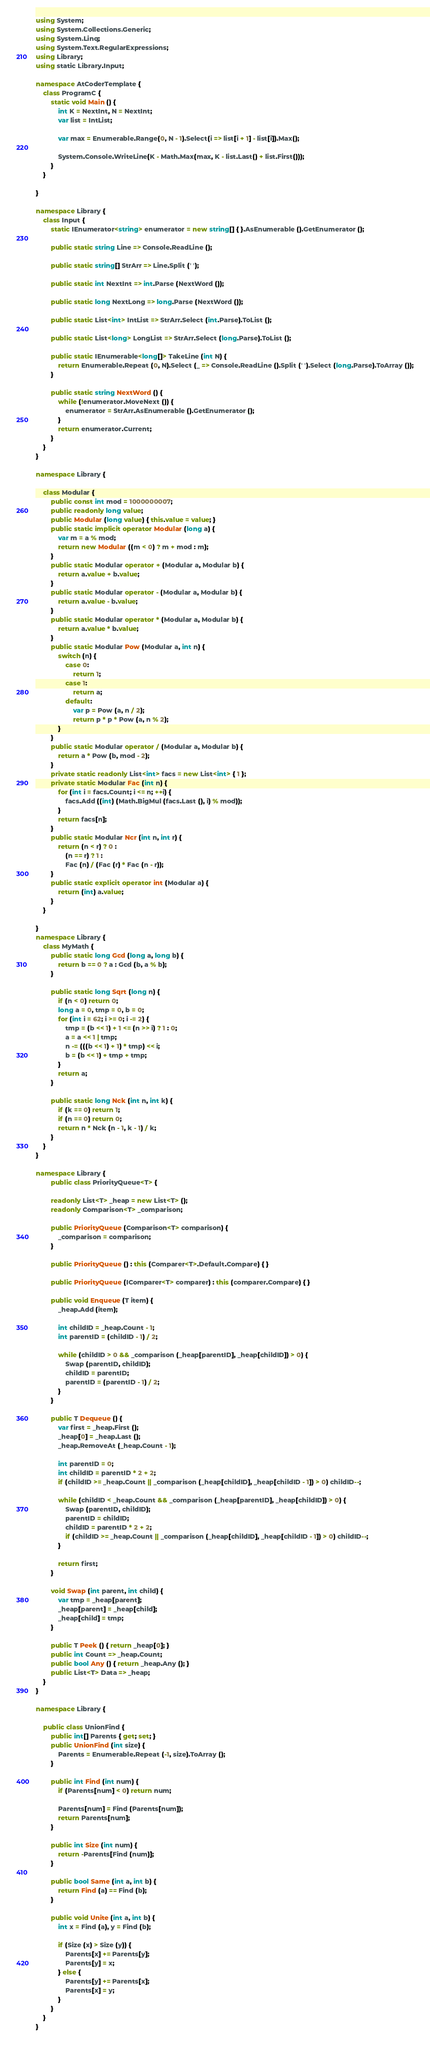Convert code to text. <code><loc_0><loc_0><loc_500><loc_500><_C#_>using System;
using System.Collections.Generic;
using System.Linq;
using System.Text.RegularExpressions;
using Library;
using static Library.Input;

namespace AtCoderTemplate {
    class ProgramC {
        static void Main () {
            int K = NextInt, N = NextInt;
            var list = IntList;

            var max = Enumerable.Range(0, N - 1).Select(i => list[i + 1] - list[i]).Max();

            System.Console.WriteLine(K - Math.Max(max, K - list.Last() + list.First()));
        }
    }

}

namespace Library {
    class Input {
        static IEnumerator<string> enumerator = new string[] { }.AsEnumerable ().GetEnumerator ();

        public static string Line => Console.ReadLine ();

        public static string[] StrArr => Line.Split (' ');

        public static int NextInt => int.Parse (NextWord ());

        public static long NextLong => long.Parse (NextWord ());

        public static List<int> IntList => StrArr.Select (int.Parse).ToList ();

        public static List<long> LongList => StrArr.Select (long.Parse).ToList ();

        public static IEnumerable<long[]> TakeLine (int N) {
            return Enumerable.Repeat (0, N).Select (_ => Console.ReadLine ().Split (' ').Select (long.Parse).ToArray ());
        }

        public static string NextWord () {
            while (!enumerator.MoveNext ()) {
                enumerator = StrArr.AsEnumerable ().GetEnumerator ();
            }
            return enumerator.Current;
        }
    }
}

namespace Library {
    
    class Modular {
        public const int mod = 1000000007;
        public readonly long value;
        public Modular (long value) { this.value = value; }
        public static implicit operator Modular (long a) {
            var m = a % mod;
            return new Modular ((m < 0) ? m + mod : m);
        }
        public static Modular operator + (Modular a, Modular b) {
            return a.value + b.value;
        }
        public static Modular operator - (Modular a, Modular b) {
            return a.value - b.value;
        }
        public static Modular operator * (Modular a, Modular b) {
            return a.value * b.value;
        }
        public static Modular Pow (Modular a, int n) {
            switch (n) {
                case 0:
                    return 1;
                case 1:
                    return a;
                default:
                    var p = Pow (a, n / 2);
                    return p * p * Pow (a, n % 2);
            }
        }
        public static Modular operator / (Modular a, Modular b) {
            return a * Pow (b, mod - 2);
        }
        private static readonly List<int> facs = new List<int> { 1 };
        private static Modular Fac (int n) {
            for (int i = facs.Count; i <= n; ++i) {
                facs.Add ((int) (Math.BigMul (facs.Last (), i) % mod));
            }
            return facs[n];
        }
        public static Modular Ncr (int n, int r) {
            return (n < r) ? 0 :
                (n == r) ? 1 :
                Fac (n) / (Fac (r) * Fac (n - r));
        }
        public static explicit operator int (Modular a) {
            return (int) a.value;
        }
    }

}
namespace Library {
    class MyMath {
        public static long Gcd (long a, long b) {
            return b == 0 ? a : Gcd (b, a % b);
        }

        public static long Sqrt (long n) {
            if (n < 0) return 0;
            long a = 0, tmp = 0, b = 0;
            for (int i = 62; i >= 0; i -= 2) {
                tmp = (b << 1) + 1 <= (n >> i) ? 1 : 0;
                a = a << 1 | tmp;
                n -= (((b << 1) + 1) * tmp) << i;
                b = (b << 1) + tmp + tmp;
            }
            return a;
        }

        public static long Nck (int n, int k) {
            if (k == 0) return 1;
            if (n == 0) return 0;
            return n * Nck (n - 1, k - 1) / k;
        }
    }
}

namespace Library {
        public class PriorityQueue<T> {

        readonly List<T> _heap = new List<T> ();
        readonly Comparison<T> _comparison;

        public PriorityQueue (Comparison<T> comparison) {
            _comparison = comparison;
        }

        public PriorityQueue () : this (Comparer<T>.Default.Compare) { }

        public PriorityQueue (IComparer<T> comparer) : this (comparer.Compare) { }

        public void Enqueue (T item) {
            _heap.Add (item);

            int childID = _heap.Count - 1;
            int parentID = (childID - 1) / 2;

            while (childID > 0 && _comparison (_heap[parentID], _heap[childID]) > 0) {
                Swap (parentID, childID);
                childID = parentID;
                parentID = (parentID - 1) / 2;
            }
        }

        public T Dequeue () {
            var first = _heap.First ();
            _heap[0] = _heap.Last ();
            _heap.RemoveAt (_heap.Count - 1);

            int parentID = 0;
            int childID = parentID * 2 + 2;
            if (childID >= _heap.Count || _comparison (_heap[childID], _heap[childID - 1]) > 0) childID--;

            while (childID < _heap.Count && _comparison (_heap[parentID], _heap[childID]) > 0) {
                Swap (parentID, childID);
                parentID = childID;
                childID = parentID * 2 + 2;
                if (childID >= _heap.Count || _comparison (_heap[childID], _heap[childID - 1]) > 0) childID--;
            }

            return first;
        }

        void Swap (int parent, int child) {
            var tmp = _heap[parent];
            _heap[parent] = _heap[child];
            _heap[child] = tmp;
        }

        public T Peek () { return _heap[0]; }
        public int Count => _heap.Count;
        public bool Any () { return _heap.Any (); }
        public List<T> Data => _heap;
    }
}

namespace Library {
    
    public class UnionFind {
        public int[] Parents { get; set; }
        public UnionFind (int size) {
            Parents = Enumerable.Repeat (-1, size).ToArray ();
        }

        public int Find (int num) {
            if (Parents[num] < 0) return num;

            Parents[num] = Find (Parents[num]);
            return Parents[num];
        }

        public int Size (int num) {
            return -Parents[Find (num)];
        }

        public bool Same (int a, int b) {
            return Find (a) == Find (b);
        }

        public void Unite (int a, int b) {
            int x = Find (a), y = Find (b);

            if (Size (x) > Size (y)) {
                Parents[x] += Parents[y];
                Parents[y] = x;
            } else {
                Parents[y] += Parents[x];
                Parents[x] = y;
            }
        }
    }
}
</code> 